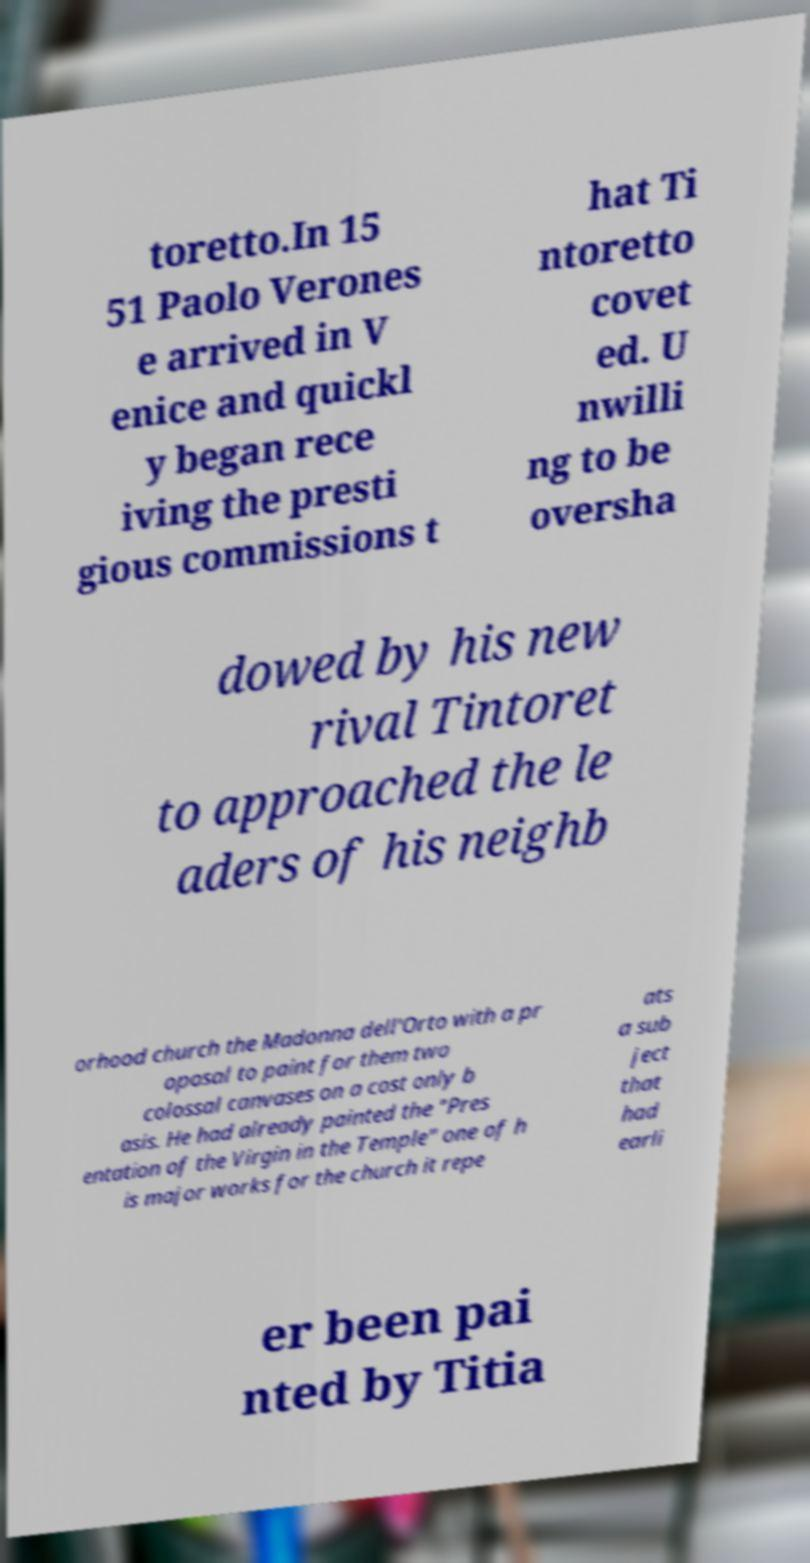Please identify and transcribe the text found in this image. toretto.In 15 51 Paolo Verones e arrived in V enice and quickl y began rece iving the presti gious commissions t hat Ti ntoretto covet ed. U nwilli ng to be oversha dowed by his new rival Tintoret to approached the le aders of his neighb orhood church the Madonna dell'Orto with a pr oposal to paint for them two colossal canvases on a cost only b asis. He had already painted the "Pres entation of the Virgin in the Temple" one of h is major works for the church it repe ats a sub ject that had earli er been pai nted by Titia 